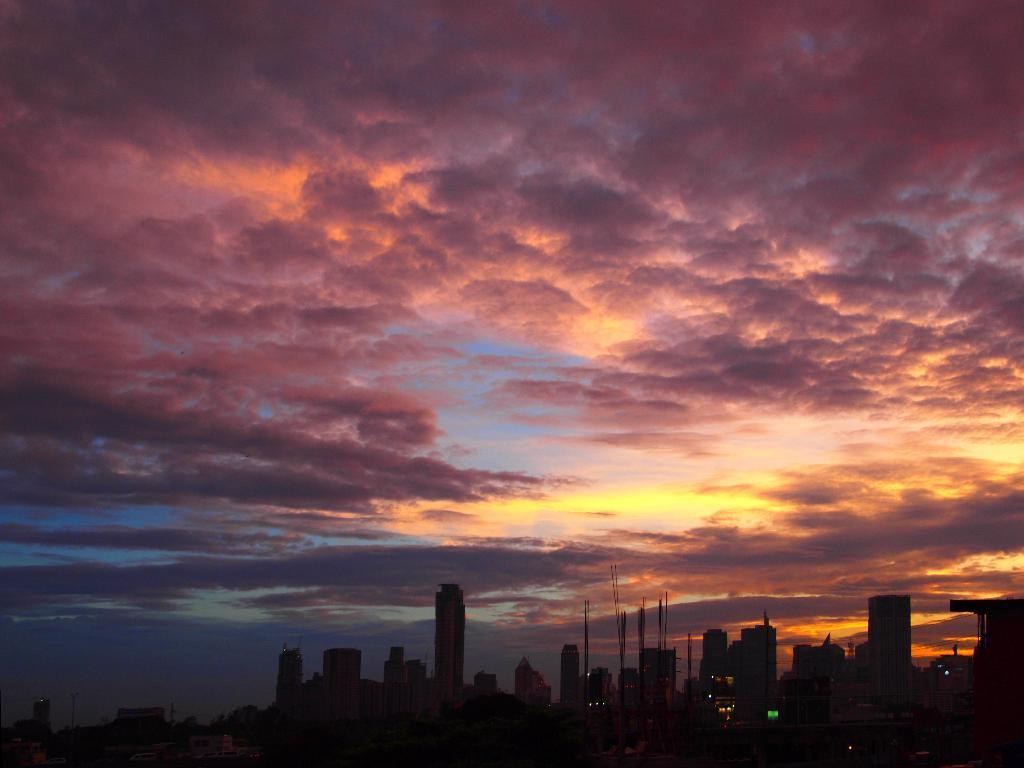What type of setting is depicted in the image? The image is an outdoor scene. What can be seen in the sky in the image? There are clouds visible in the image, and the sky is blue. What structures are present in the image? There are buildings in the image. What time of day does the image appear to represent? The time of day appears to be evening. What emotion is the building feeling in the image? Buildings do not have emotions, so this question cannot be answered. 